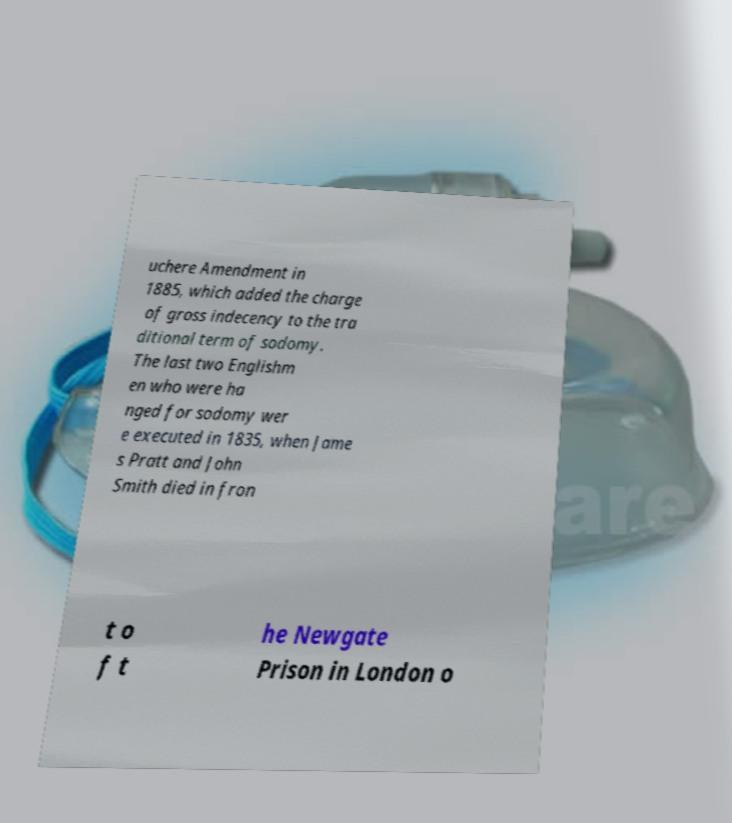I need the written content from this picture converted into text. Can you do that? uchere Amendment in 1885, which added the charge of gross indecency to the tra ditional term of sodomy. The last two Englishm en who were ha nged for sodomy wer e executed in 1835, when Jame s Pratt and John Smith died in fron t o f t he Newgate Prison in London o 